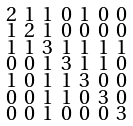Convert formula to latex. <formula><loc_0><loc_0><loc_500><loc_500>\begin{smallmatrix} 2 & 1 & 1 & 0 & 1 & 0 & 0 \\ 1 & 2 & 1 & 0 & 0 & 0 & 0 \\ 1 & 1 & 3 & 1 & 1 & 1 & 1 \\ 0 & 0 & 1 & 3 & 1 & 1 & 0 \\ 1 & 0 & 1 & 1 & 3 & 0 & 0 \\ 0 & 0 & 1 & 1 & 0 & 3 & 0 \\ 0 & 0 & 1 & 0 & 0 & 0 & 3 \end{smallmatrix}</formula> 